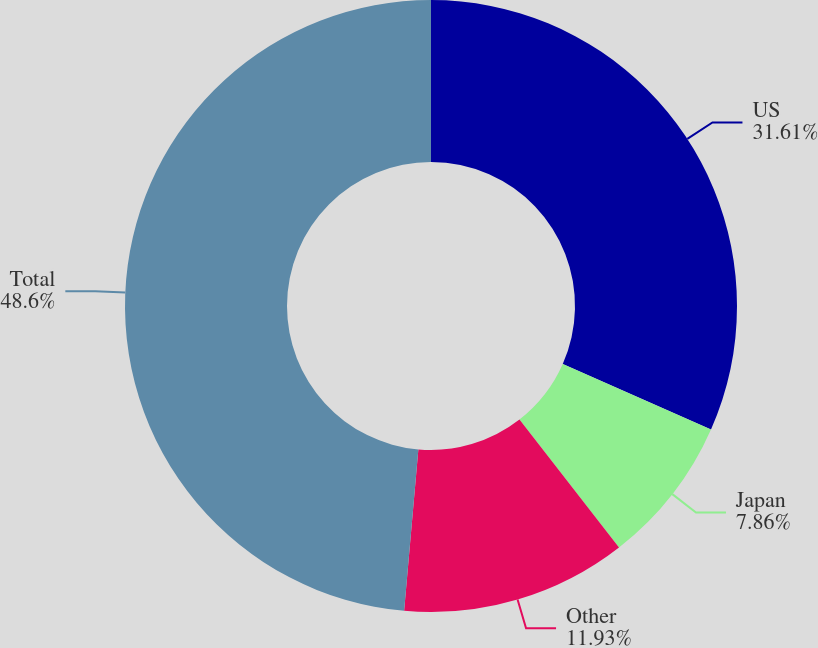Convert chart. <chart><loc_0><loc_0><loc_500><loc_500><pie_chart><fcel>US<fcel>Japan<fcel>Other<fcel>Total<nl><fcel>31.61%<fcel>7.86%<fcel>11.93%<fcel>48.6%<nl></chart> 